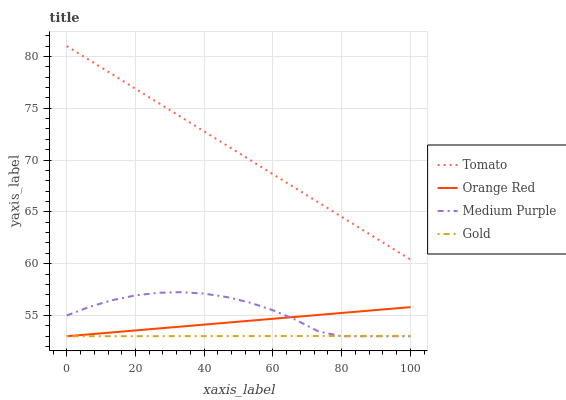Does Medium Purple have the minimum area under the curve?
Answer yes or no. No. Does Medium Purple have the maximum area under the curve?
Answer yes or no. No. Is Orange Red the smoothest?
Answer yes or no. No. Is Orange Red the roughest?
Answer yes or no. No. Does Medium Purple have the highest value?
Answer yes or no. No. Is Medium Purple less than Tomato?
Answer yes or no. Yes. Is Tomato greater than Medium Purple?
Answer yes or no. Yes. Does Medium Purple intersect Tomato?
Answer yes or no. No. 